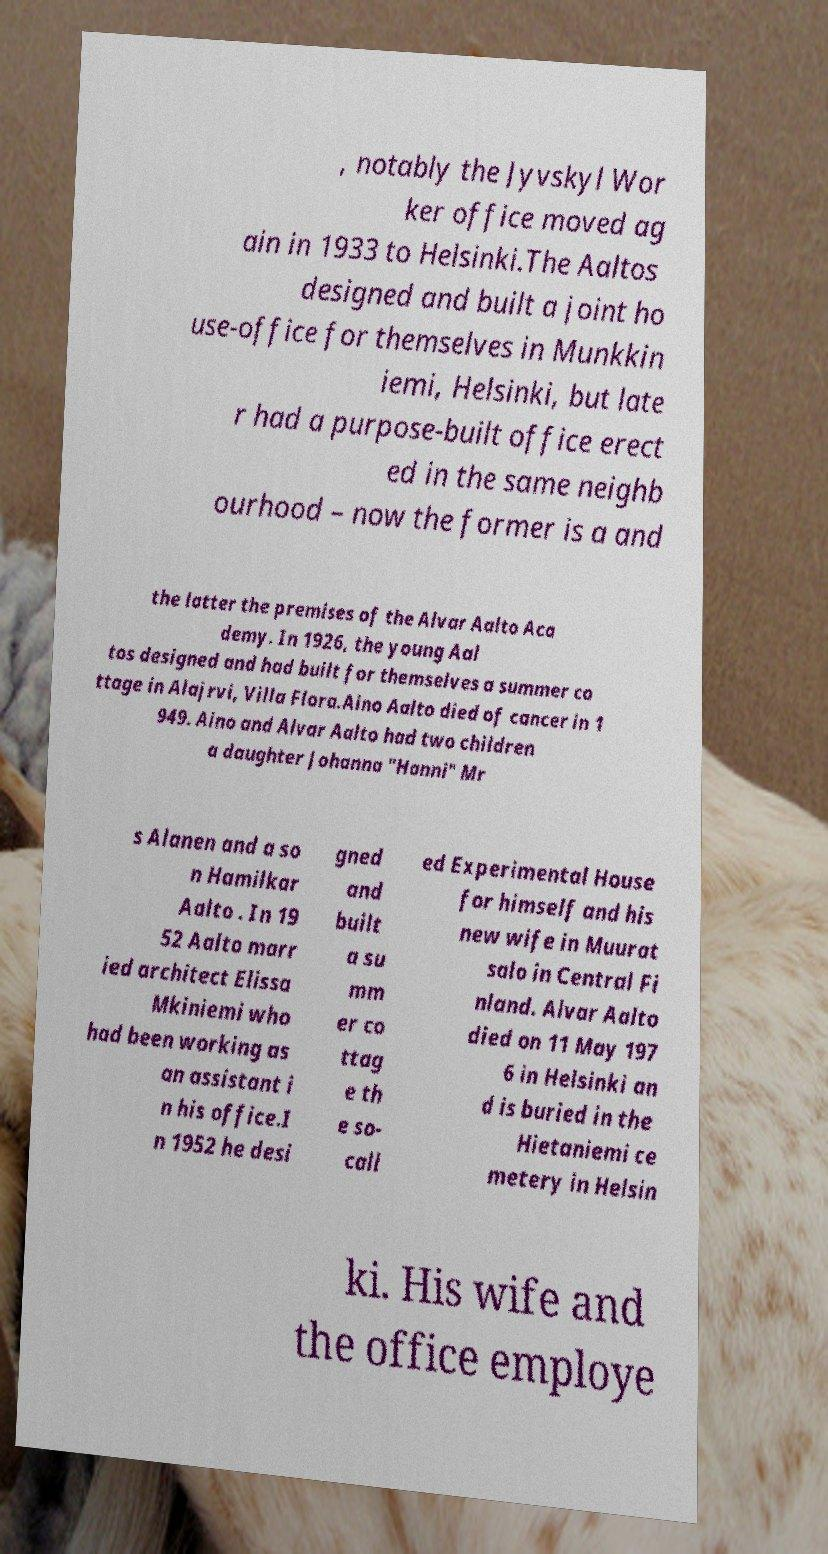I need the written content from this picture converted into text. Can you do that? , notably the Jyvskyl Wor ker office moved ag ain in 1933 to Helsinki.The Aaltos designed and built a joint ho use-office for themselves in Munkkin iemi, Helsinki, but late r had a purpose-built office erect ed in the same neighb ourhood – now the former is a and the latter the premises of the Alvar Aalto Aca demy. In 1926, the young Aal tos designed and had built for themselves a summer co ttage in Alajrvi, Villa Flora.Aino Aalto died of cancer in 1 949. Aino and Alvar Aalto had two children a daughter Johanna "Hanni" Mr s Alanen and a so n Hamilkar Aalto . In 19 52 Aalto marr ied architect Elissa Mkiniemi who had been working as an assistant i n his office.I n 1952 he desi gned and built a su mm er co ttag e th e so- call ed Experimental House for himself and his new wife in Muurat salo in Central Fi nland. Alvar Aalto died on 11 May 197 6 in Helsinki an d is buried in the Hietaniemi ce metery in Helsin ki. His wife and the office employe 